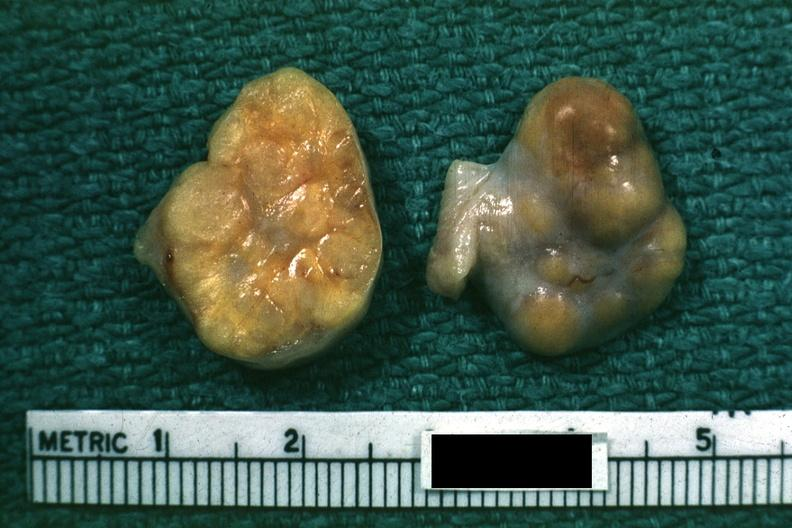what is this good yellow color slide labeled tumor?
Answer the question using a single word or phrase. Labeled granulosa cell 